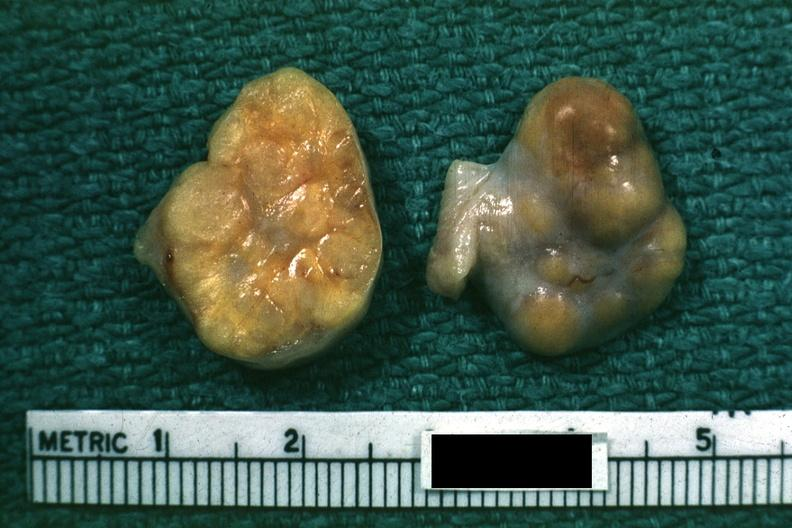what is this good yellow color slide labeled tumor?
Answer the question using a single word or phrase. Labeled granulosa cell 